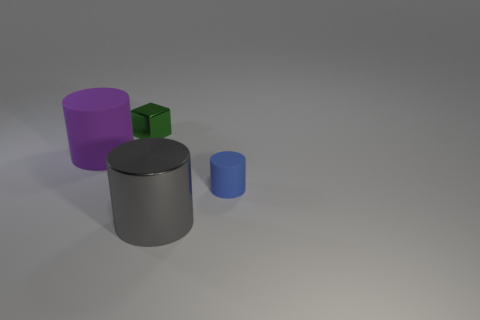Is there any other thing that is the same material as the tiny block?
Give a very brief answer. Yes. How many objects are things that are left of the blue matte cylinder or purple matte cylinders?
Ensure brevity in your answer.  3. Are there any big shiny things that are behind the metallic object that is in front of the cylinder that is behind the small matte cylinder?
Keep it short and to the point. No. How many blue matte objects are there?
Offer a very short reply. 1. What number of things are rubber cylinders right of the purple rubber thing or objects that are to the right of the block?
Provide a short and direct response. 2. There is a metallic thing on the right side of the green cube; is its size the same as the big purple cylinder?
Provide a succinct answer. Yes. The metallic thing that is the same shape as the purple matte thing is what size?
Make the answer very short. Large. There is a thing that is the same size as the metal cylinder; what material is it?
Your response must be concise. Rubber. What is the material of the small blue object that is the same shape as the gray metallic thing?
Your answer should be very brief. Rubber. How many other objects are there of the same size as the gray cylinder?
Keep it short and to the point. 1. 